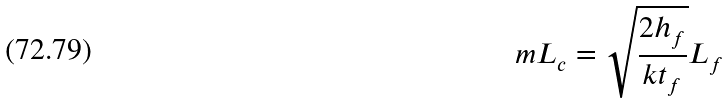Convert formula to latex. <formula><loc_0><loc_0><loc_500><loc_500>m L _ { c } = \sqrt { \frac { 2 h _ { f } } { k t _ { f } } } L _ { f }</formula> 